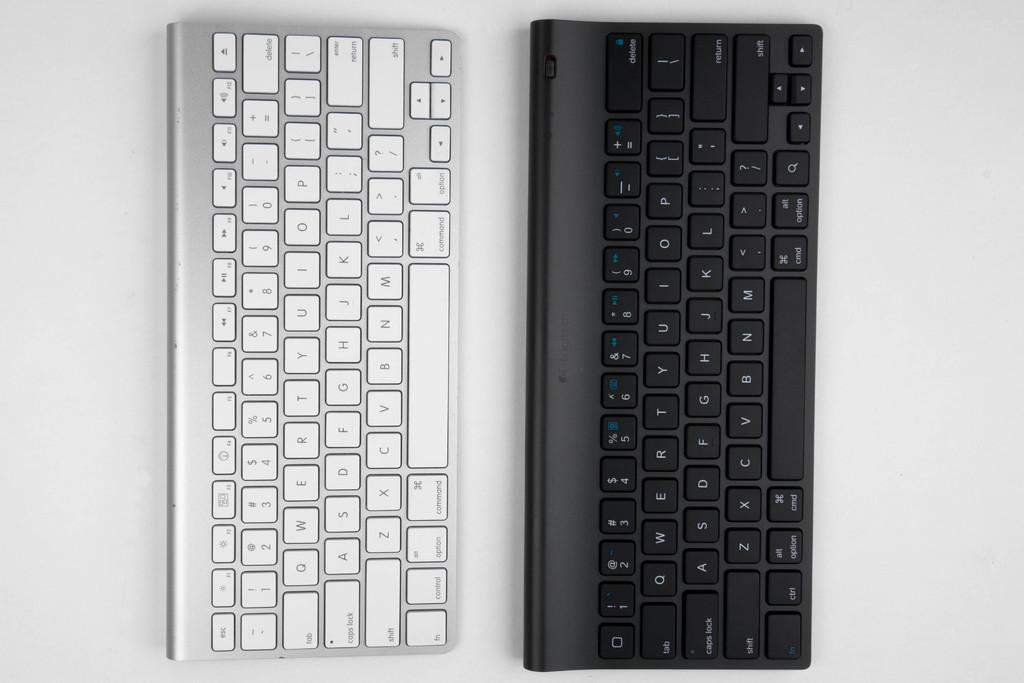<image>
Summarize the visual content of the image. A black keyboard has a "fn" key right under the left-most "shift" button. 